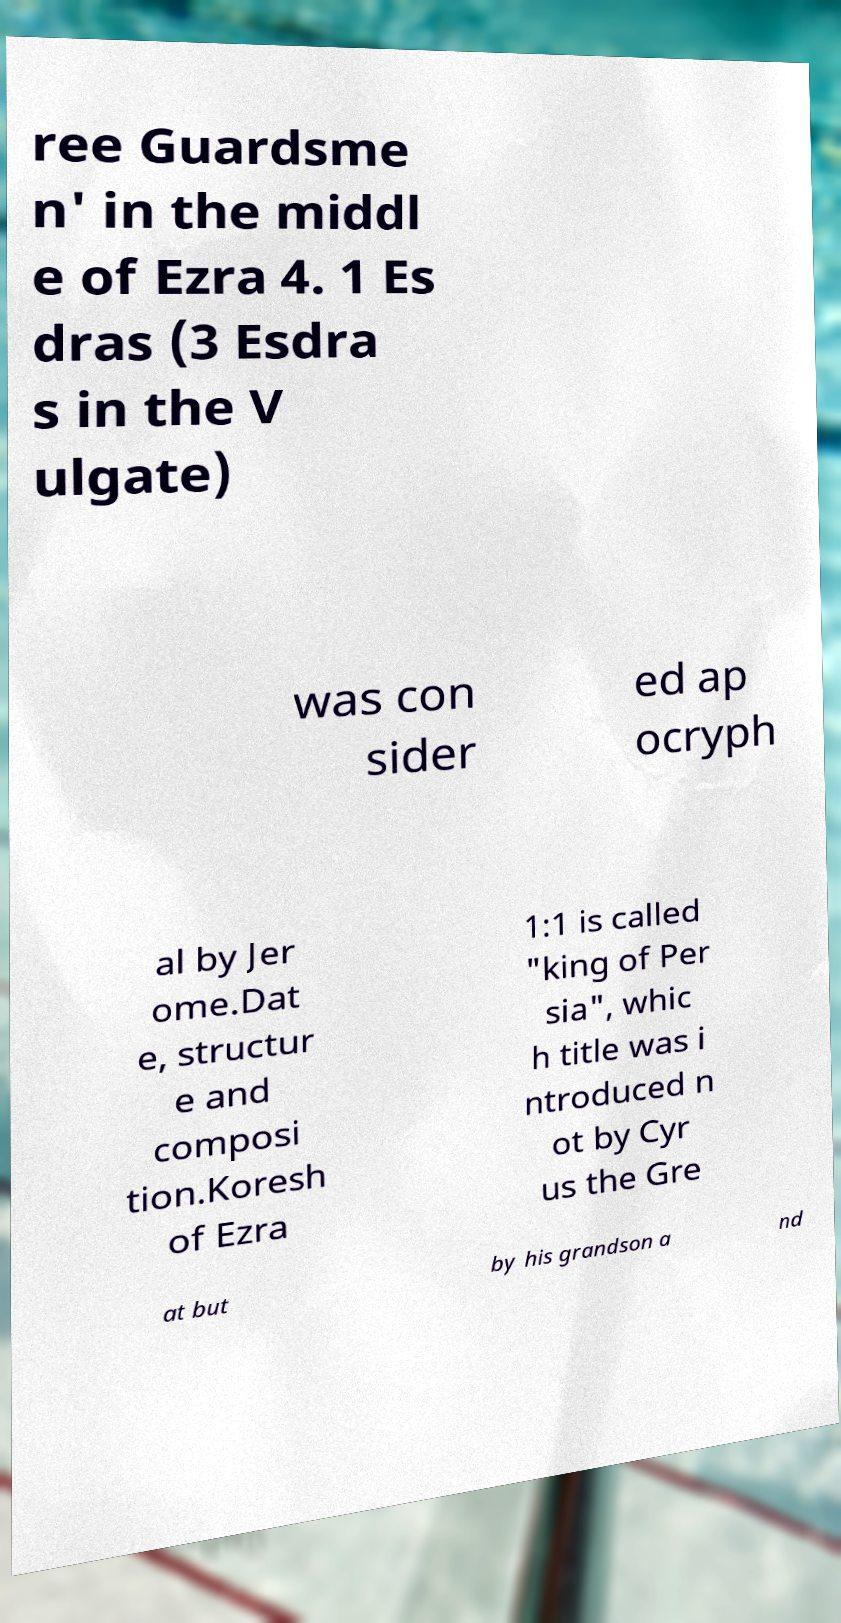I need the written content from this picture converted into text. Can you do that? ree Guardsme n' in the middl e of Ezra 4. 1 Es dras (3 Esdra s in the V ulgate) was con sider ed ap ocryph al by Jer ome.Dat e, structur e and composi tion.Koresh of Ezra 1:1 is called "king of Per sia", whic h title was i ntroduced n ot by Cyr us the Gre at but by his grandson a nd 